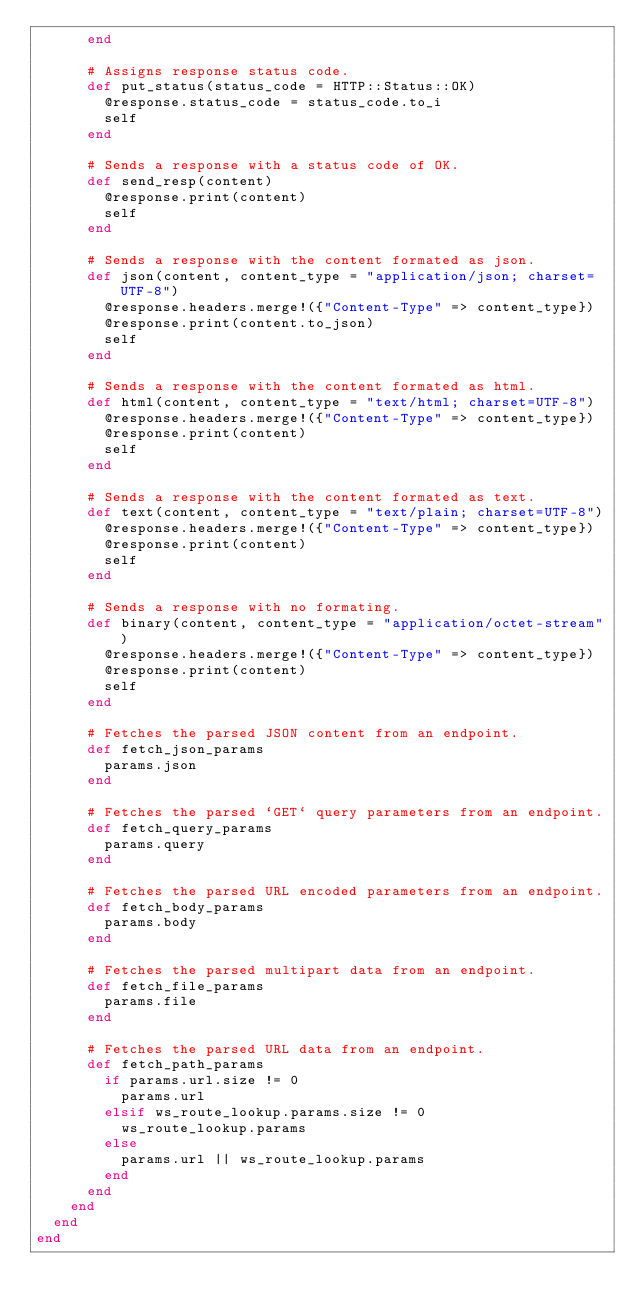Convert code to text. <code><loc_0><loc_0><loc_500><loc_500><_Crystal_>      end

      # Assigns response status code.
      def put_status(status_code = HTTP::Status::OK)
        @response.status_code = status_code.to_i
        self
      end

      # Sends a response with a status code of OK.
      def send_resp(content)
        @response.print(content)
        self
      end

      # Sends a response with the content formated as json.
      def json(content, content_type = "application/json; charset=UTF-8")
        @response.headers.merge!({"Content-Type" => content_type})
        @response.print(content.to_json)
        self
      end

      # Sends a response with the content formated as html.
      def html(content, content_type = "text/html; charset=UTF-8")
        @response.headers.merge!({"Content-Type" => content_type})
        @response.print(content)
        self
      end

      # Sends a response with the content formated as text.
      def text(content, content_type = "text/plain; charset=UTF-8")
        @response.headers.merge!({"Content-Type" => content_type})
        @response.print(content)
        self
      end

      # Sends a response with no formating.
      def binary(content, content_type = "application/octet-stream")
        @response.headers.merge!({"Content-Type" => content_type})
        @response.print(content)
        self
      end

      # Fetches the parsed JSON content from an endpoint.
      def fetch_json_params
        params.json
      end

      # Fetches the parsed `GET` query parameters from an endpoint.
      def fetch_query_params
        params.query
      end

      # Fetches the parsed URL encoded parameters from an endpoint.
      def fetch_body_params
        params.body
      end

      # Fetches the parsed multipart data from an endpoint.
      def fetch_file_params
        params.file
      end

      # Fetches the parsed URL data from an endpoint.
      def fetch_path_params
        if params.url.size != 0
          params.url
        elsif ws_route_lookup.params.size != 0
          ws_route_lookup.params
        else
          params.url || ws_route_lookup.params
        end
      end
    end
  end
end
</code> 